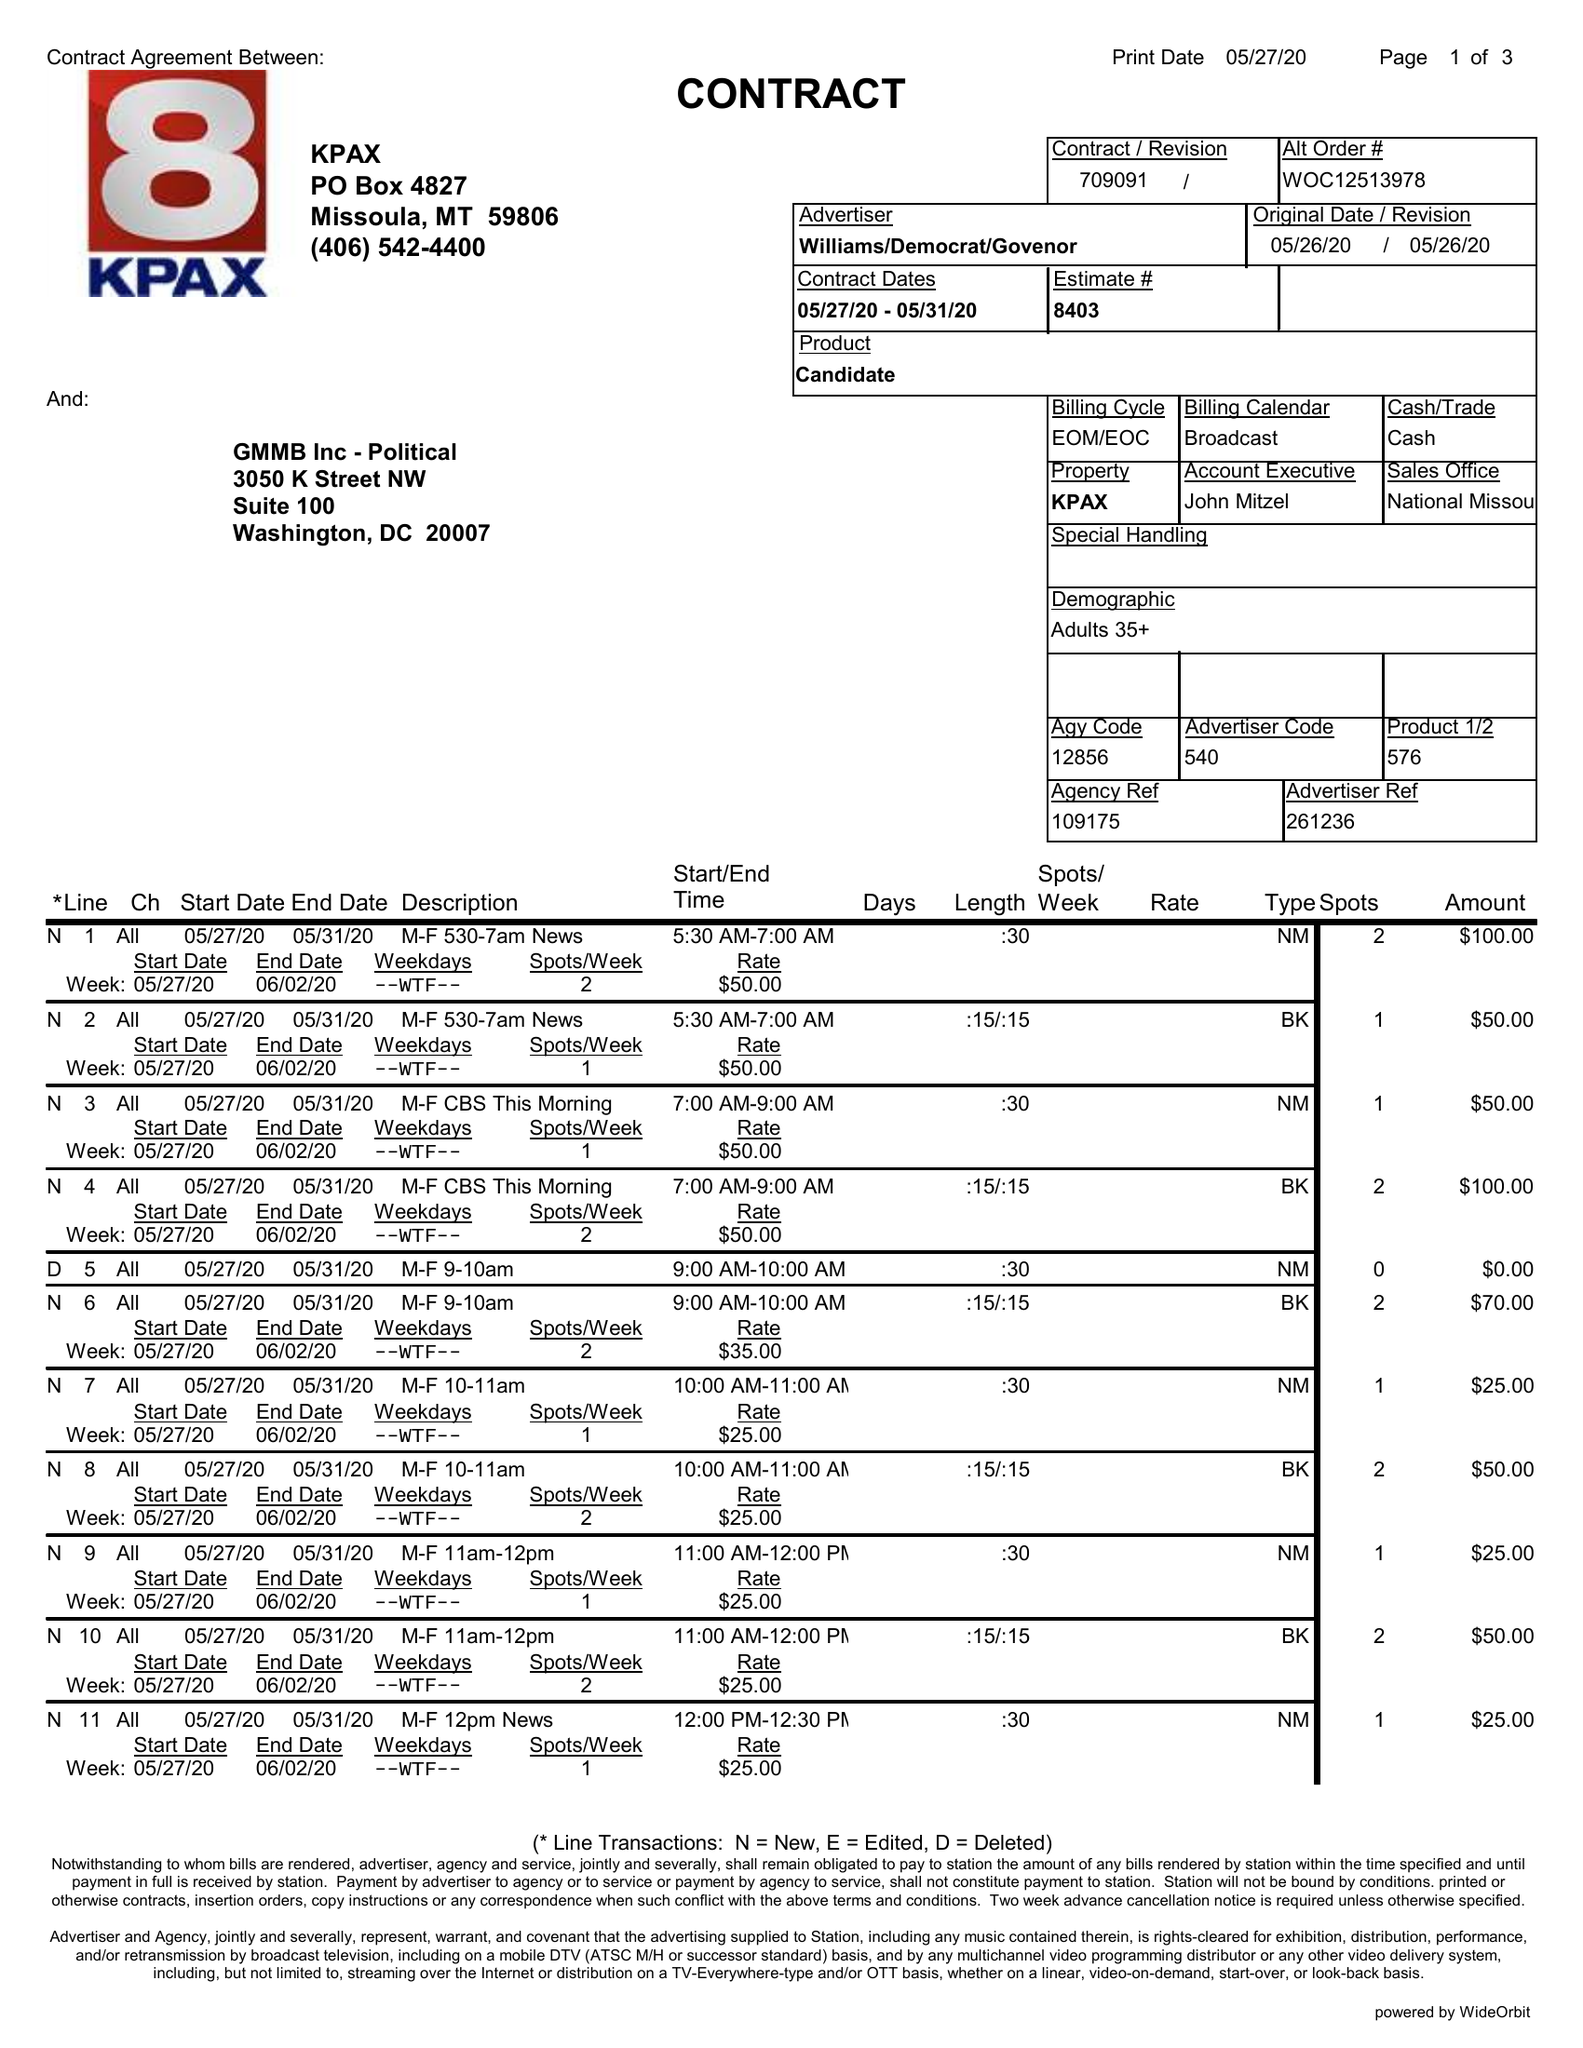What is the value for the advertiser?
Answer the question using a single word or phrase. WILLIAMS/DEMOCRAT/GOVENOR 